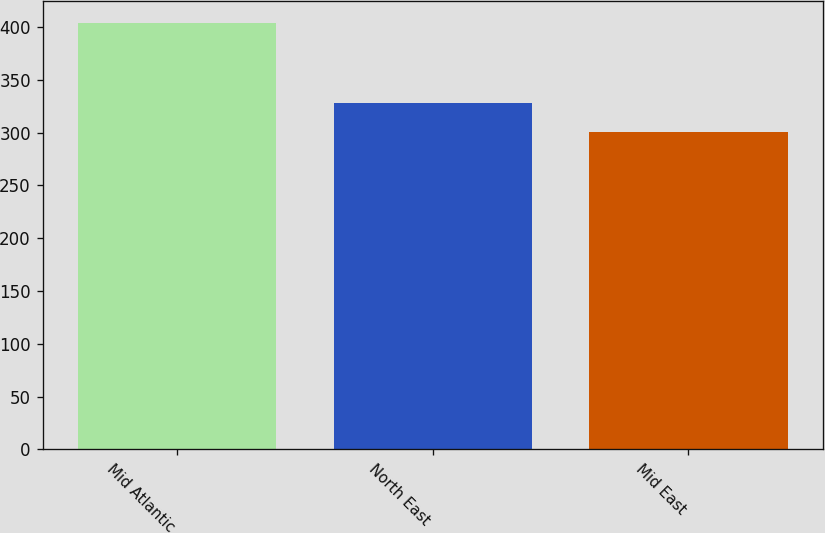<chart> <loc_0><loc_0><loc_500><loc_500><bar_chart><fcel>Mid Atlantic<fcel>North East<fcel>Mid East<nl><fcel>404<fcel>328.4<fcel>300.4<nl></chart> 